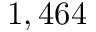<formula> <loc_0><loc_0><loc_500><loc_500>1 , 4 6 4</formula> 